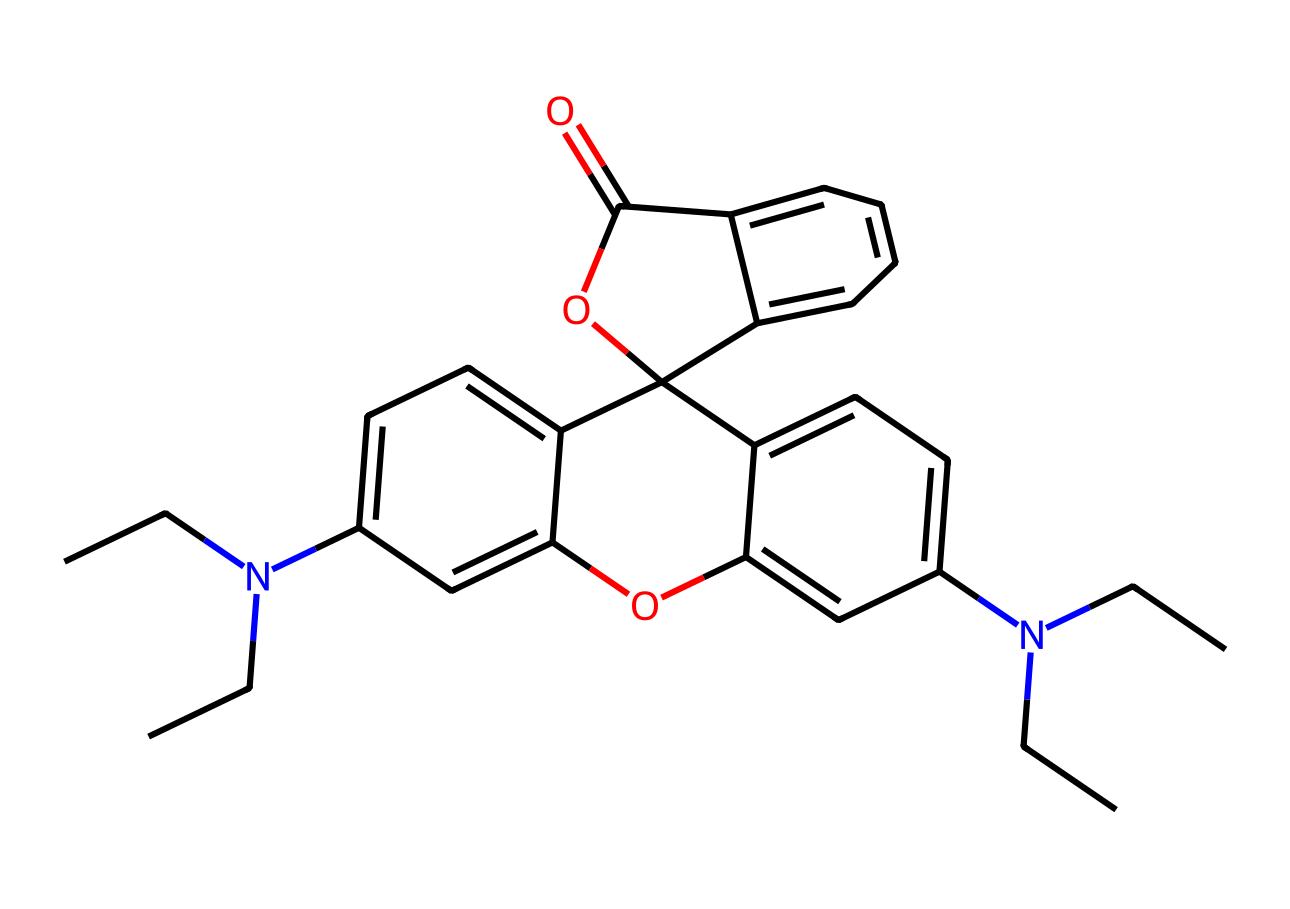What is the primary functional group present in rhodamine B? The chemical structure contains a hydroxyl group (-OH) and an amine group (-NH), which are essential functional groups. However, the phenolic -OH is more prominent in dyes for fluorescence.
Answer: hydroxyl How many nitrogen atoms are present in the rhodamine B structure? By examining the SMILES representation, we can identify two nitrogen atoms represented by 'N' in the structure, indicating their presence in the chemical.
Answer: 2 What is the total number of aromatic rings in rhodamine B? Upon analysis of the structure, there are three distinct aromatic rings visible. The connections around these rings confirm their aromatic nature.
Answer: 3 What is a significant color property of rhodamine B? Rhodamine B is well-known for its intense fluorescent properties, characterized by its bright pink color in solution under UV light.
Answer: fluorescent What type of dye is rhodamine B classified as? Rhodamine B is identified as a synthetic dye used mainly for fluorescence, often in biological and chemical applications. A detailed look at its molecular structure supports its classification.
Answer: synthetic What is the molecular weight of rhodamine B? The molecular formula derived from the structure corresponds to a molecular weight of approximately 479.02 g/mol based on the weighted composition of its atoms.
Answer: 479.02 g/mol 